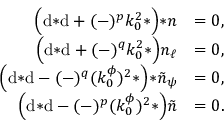Convert formula to latex. <formula><loc_0><loc_0><loc_500><loc_500>\begin{array} { r l } { \left ( d { * d } + ( - ) ^ { p } k _ { 0 } ^ { 2 } { * } \right ) { * n } } & { = 0 , } \\ { \left ( d { * d } + ( - ) ^ { q } k _ { 0 } ^ { 2 } { * } \right ) n _ { \ell } } & { = 0 , } \\ { \left ( d { * d } - ( - ) ^ { q } ( k _ { 0 } ^ { \phi } ) ^ { 2 } { * } \right ) { * \tilde { n } _ { \psi } } } & { = 0 , } \\ { \left ( d { * d } - ( - ) ^ { p } ( k _ { 0 } ^ { \phi } ) ^ { 2 } { * } \right ) \tilde { n } } & { = 0 . } \end{array}</formula> 